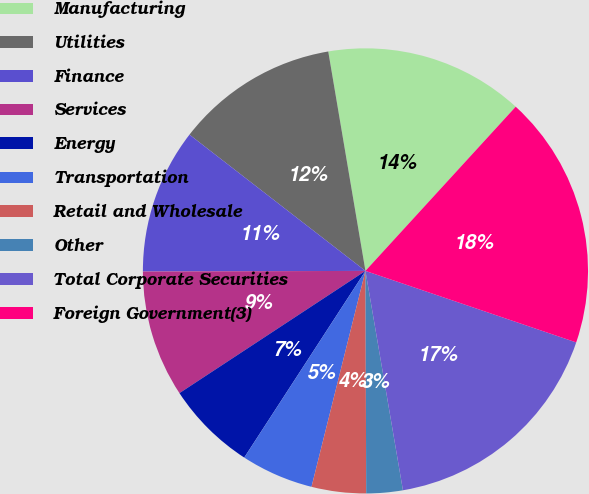Convert chart. <chart><loc_0><loc_0><loc_500><loc_500><pie_chart><fcel>Manufacturing<fcel>Utilities<fcel>Finance<fcel>Services<fcel>Energy<fcel>Transportation<fcel>Retail and Wholesale<fcel>Other<fcel>Total Corporate Securities<fcel>Foreign Government(3)<nl><fcel>14.47%<fcel>11.84%<fcel>10.53%<fcel>9.21%<fcel>6.58%<fcel>5.27%<fcel>3.95%<fcel>2.64%<fcel>17.1%<fcel>18.41%<nl></chart> 